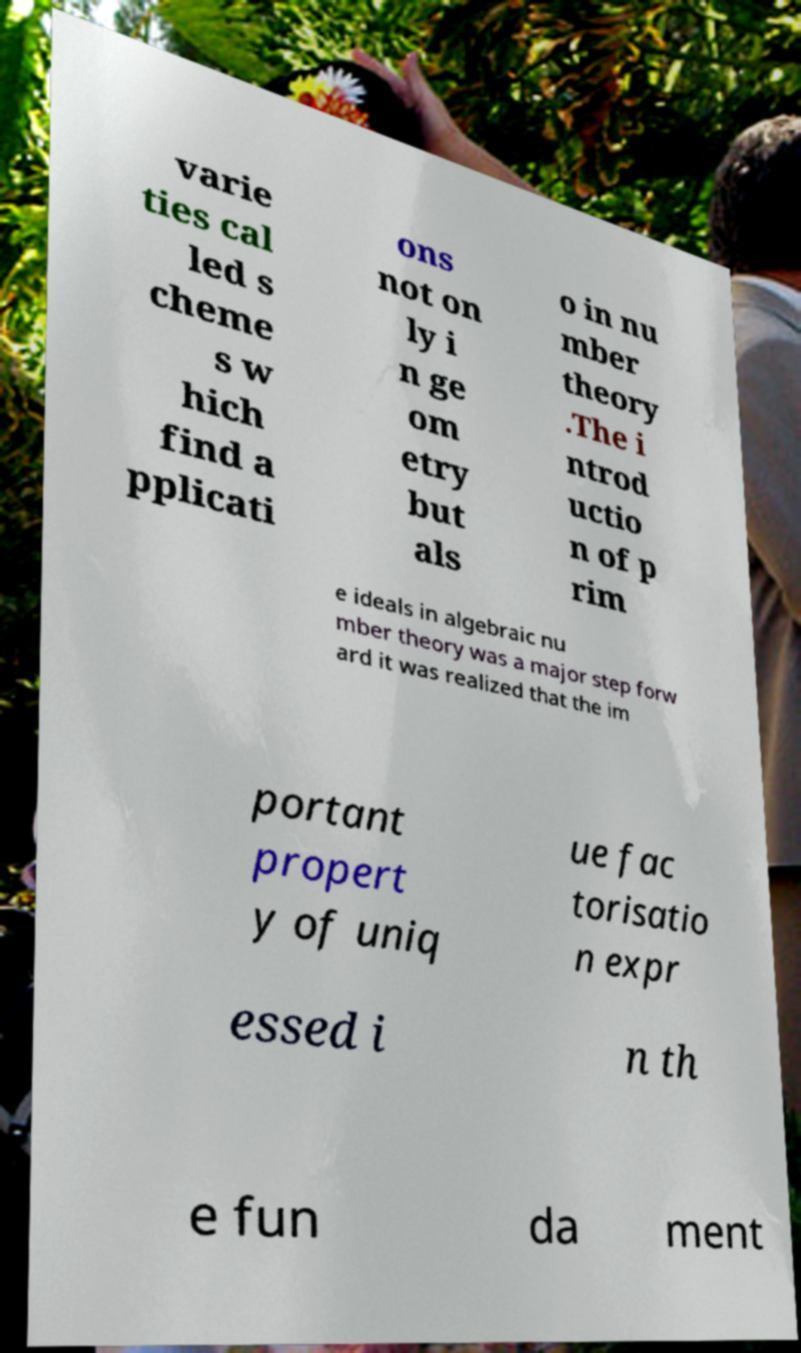There's text embedded in this image that I need extracted. Can you transcribe it verbatim? varie ties cal led s cheme s w hich find a pplicati ons not on ly i n ge om etry but als o in nu mber theory .The i ntrod uctio n of p rim e ideals in algebraic nu mber theory was a major step forw ard it was realized that the im portant propert y of uniq ue fac torisatio n expr essed i n th e fun da ment 